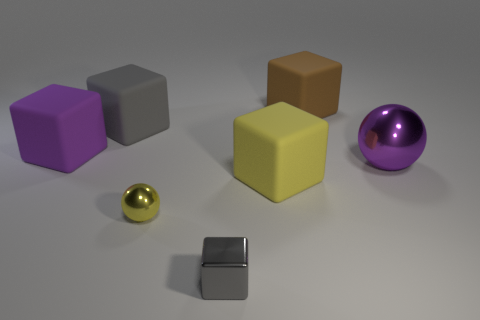Can you guess the possible material of the silver object on the right? The silver object on the right looks like it could be made of metal, owing to its reflective surface and sharp edges. It resembles the finish you might see on brushed stainless steel, which often has a slightly matte sheen. 